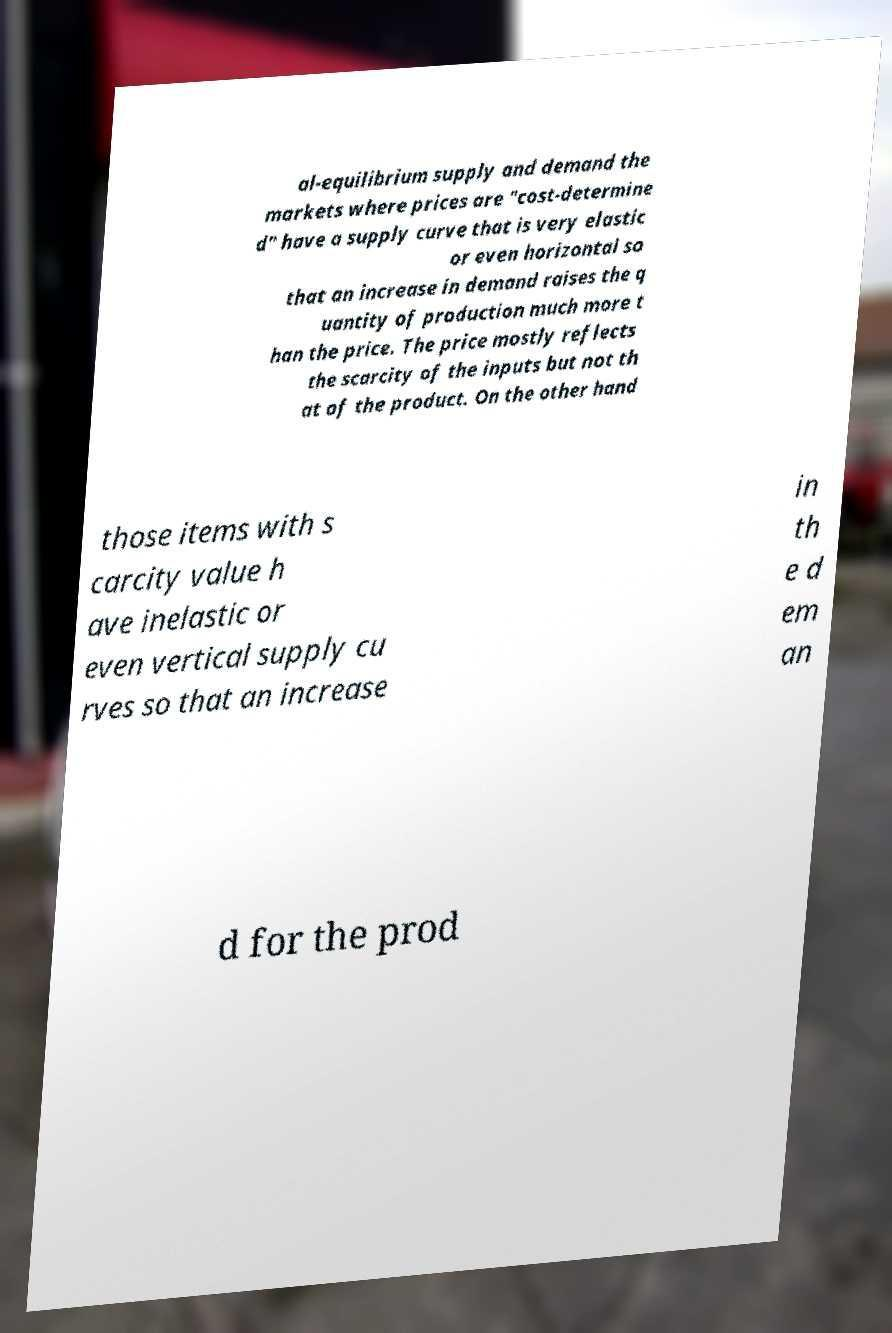There's text embedded in this image that I need extracted. Can you transcribe it verbatim? al-equilibrium supply and demand the markets where prices are "cost-determine d" have a supply curve that is very elastic or even horizontal so that an increase in demand raises the q uantity of production much more t han the price. The price mostly reflects the scarcity of the inputs but not th at of the product. On the other hand those items with s carcity value h ave inelastic or even vertical supply cu rves so that an increase in th e d em an d for the prod 